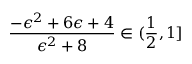Convert formula to latex. <formula><loc_0><loc_0><loc_500><loc_500>\frac { - \epsilon ^ { 2 } + 6 \epsilon + 4 } { \epsilon ^ { 2 } + 8 } \in ( \frac { 1 } { 2 } , 1 ]</formula> 